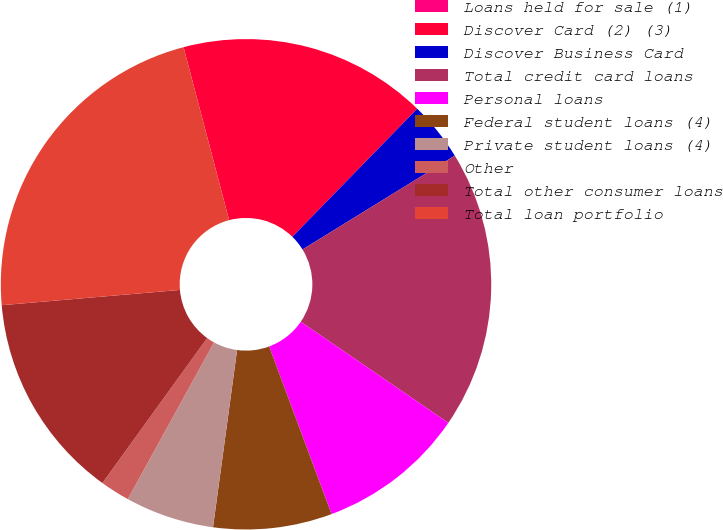Convert chart to OTSL. <chart><loc_0><loc_0><loc_500><loc_500><pie_chart><fcel>Loans held for sale (1)<fcel>Discover Card (2) (3)<fcel>Discover Business Card<fcel>Total credit card loans<fcel>Personal loans<fcel>Federal student loans (4)<fcel>Private student loans (4)<fcel>Other<fcel>Total other consumer loans<fcel>Total loan portfolio<nl><fcel>0.0%<fcel>16.4%<fcel>3.91%<fcel>18.35%<fcel>9.77%<fcel>7.82%<fcel>5.86%<fcel>1.95%<fcel>13.68%<fcel>22.26%<nl></chart> 